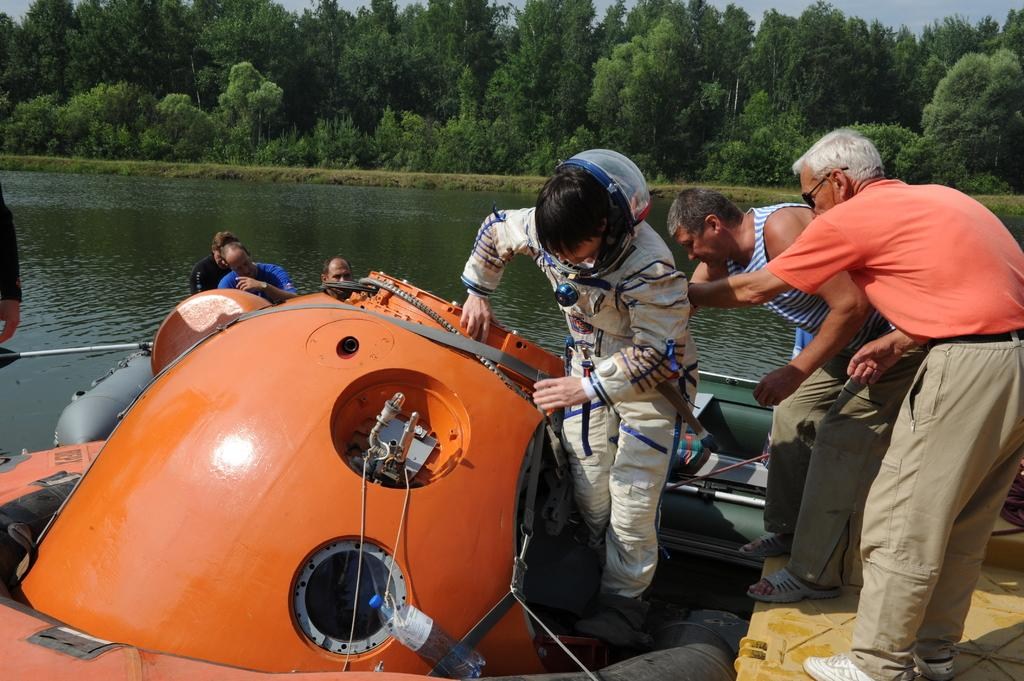What are the people in the image doing? The people in the image are standing on a boat. What can be seen in the background of the image? There is water, trees, and the sky visible in the background of the image. Can you describe the clothing of one of the people on the boat? A person in the middle of the boat is wearing a white color suit. What type of root can be seen growing on the boat in the image? There are no roots visible on the boat in the image. How does the pig contribute to the atmosphere on the boat in the image? There are no pigs present in the image; it only features people standing on a boat. 